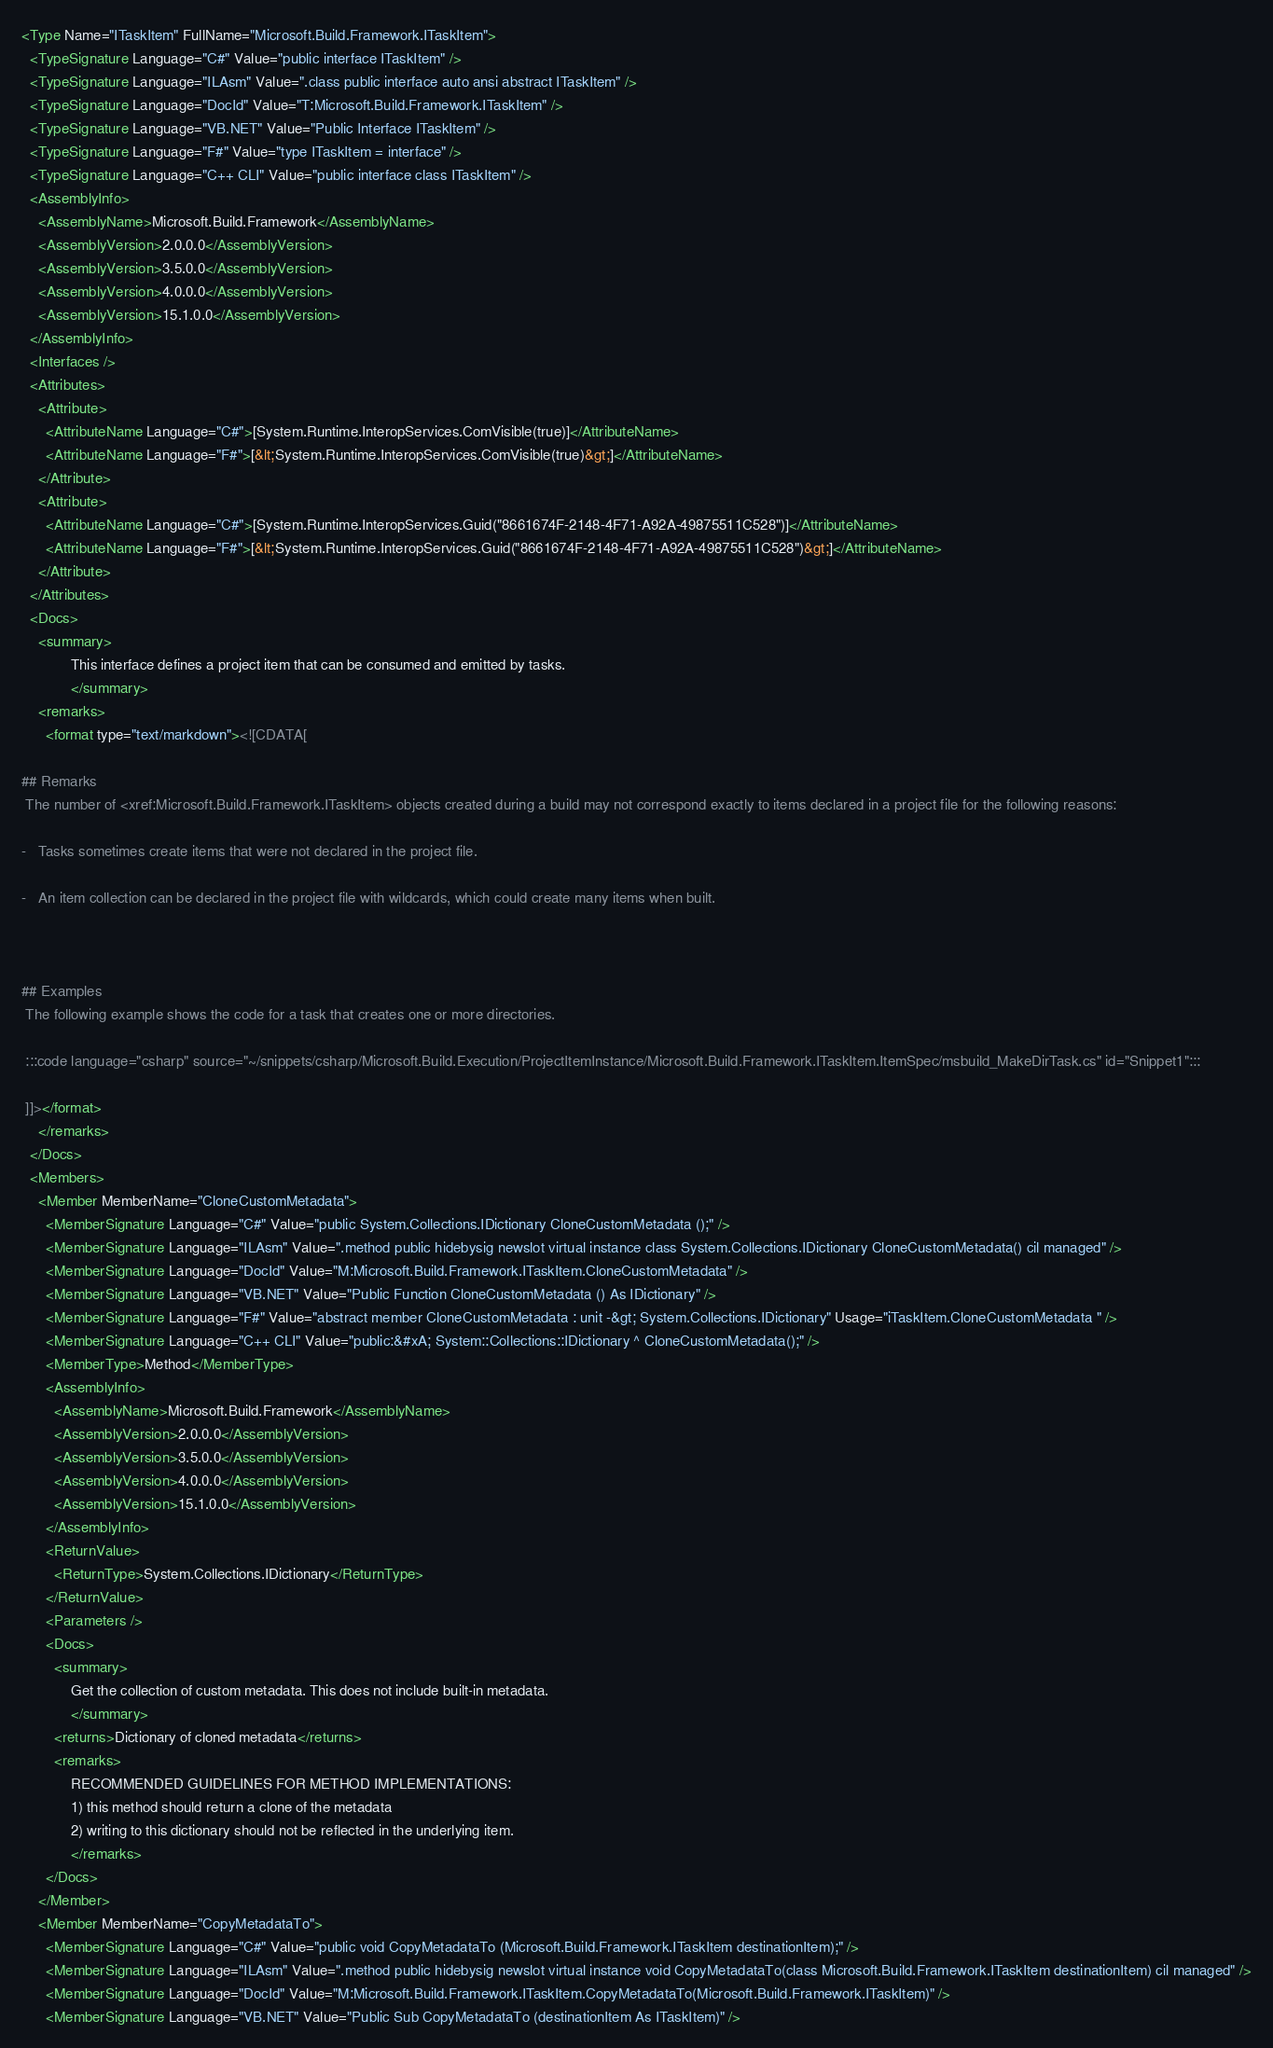Convert code to text. <code><loc_0><loc_0><loc_500><loc_500><_XML_><Type Name="ITaskItem" FullName="Microsoft.Build.Framework.ITaskItem">
  <TypeSignature Language="C#" Value="public interface ITaskItem" />
  <TypeSignature Language="ILAsm" Value=".class public interface auto ansi abstract ITaskItem" />
  <TypeSignature Language="DocId" Value="T:Microsoft.Build.Framework.ITaskItem" />
  <TypeSignature Language="VB.NET" Value="Public Interface ITaskItem" />
  <TypeSignature Language="F#" Value="type ITaskItem = interface" />
  <TypeSignature Language="C++ CLI" Value="public interface class ITaskItem" />
  <AssemblyInfo>
    <AssemblyName>Microsoft.Build.Framework</AssemblyName>
    <AssemblyVersion>2.0.0.0</AssemblyVersion>
    <AssemblyVersion>3.5.0.0</AssemblyVersion>
    <AssemblyVersion>4.0.0.0</AssemblyVersion>
    <AssemblyVersion>15.1.0.0</AssemblyVersion>
  </AssemblyInfo>
  <Interfaces />
  <Attributes>
    <Attribute>
      <AttributeName Language="C#">[System.Runtime.InteropServices.ComVisible(true)]</AttributeName>
      <AttributeName Language="F#">[&lt;System.Runtime.InteropServices.ComVisible(true)&gt;]</AttributeName>
    </Attribute>
    <Attribute>
      <AttributeName Language="C#">[System.Runtime.InteropServices.Guid("8661674F-2148-4F71-A92A-49875511C528")]</AttributeName>
      <AttributeName Language="F#">[&lt;System.Runtime.InteropServices.Guid("8661674F-2148-4F71-A92A-49875511C528")&gt;]</AttributeName>
    </Attribute>
  </Attributes>
  <Docs>
    <summary>
            This interface defines a project item that can be consumed and emitted by tasks.
            </summary>
    <remarks>
      <format type="text/markdown"><![CDATA[  
  
## Remarks  
 The number of <xref:Microsoft.Build.Framework.ITaskItem> objects created during a build may not correspond exactly to items declared in a project file for the following reasons:  
  
-   Tasks sometimes create items that were not declared in the project file.  
  
-   An item collection can be declared in the project file with wildcards, which could create many items when built.  
  
   
  
## Examples  
 The following example shows the code for a task that creates one or more directories.  
  
 :::code language="csharp" source="~/snippets/csharp/Microsoft.Build.Execution/ProjectItemInstance/Microsoft.Build.Framework.ITaskItem.ItemSpec/msbuild_MakeDirTask.cs" id="Snippet1":::  
  
 ]]></format>
    </remarks>
  </Docs>
  <Members>
    <Member MemberName="CloneCustomMetadata">
      <MemberSignature Language="C#" Value="public System.Collections.IDictionary CloneCustomMetadata ();" />
      <MemberSignature Language="ILAsm" Value=".method public hidebysig newslot virtual instance class System.Collections.IDictionary CloneCustomMetadata() cil managed" />
      <MemberSignature Language="DocId" Value="M:Microsoft.Build.Framework.ITaskItem.CloneCustomMetadata" />
      <MemberSignature Language="VB.NET" Value="Public Function CloneCustomMetadata () As IDictionary" />
      <MemberSignature Language="F#" Value="abstract member CloneCustomMetadata : unit -&gt; System.Collections.IDictionary" Usage="iTaskItem.CloneCustomMetadata " />
      <MemberSignature Language="C++ CLI" Value="public:&#xA; System::Collections::IDictionary ^ CloneCustomMetadata();" />
      <MemberType>Method</MemberType>
      <AssemblyInfo>
        <AssemblyName>Microsoft.Build.Framework</AssemblyName>
        <AssemblyVersion>2.0.0.0</AssemblyVersion>
        <AssemblyVersion>3.5.0.0</AssemblyVersion>
        <AssemblyVersion>4.0.0.0</AssemblyVersion>
        <AssemblyVersion>15.1.0.0</AssemblyVersion>
      </AssemblyInfo>
      <ReturnValue>
        <ReturnType>System.Collections.IDictionary</ReturnType>
      </ReturnValue>
      <Parameters />
      <Docs>
        <summary>
            Get the collection of custom metadata. This does not include built-in metadata.
            </summary>
        <returns>Dictionary of cloned metadata</returns>
        <remarks>
            RECOMMENDED GUIDELINES FOR METHOD IMPLEMENTATIONS:
            1) this method should return a clone of the metadata
            2) writing to this dictionary should not be reflected in the underlying item.
            </remarks>
      </Docs>
    </Member>
    <Member MemberName="CopyMetadataTo">
      <MemberSignature Language="C#" Value="public void CopyMetadataTo (Microsoft.Build.Framework.ITaskItem destinationItem);" />
      <MemberSignature Language="ILAsm" Value=".method public hidebysig newslot virtual instance void CopyMetadataTo(class Microsoft.Build.Framework.ITaskItem destinationItem) cil managed" />
      <MemberSignature Language="DocId" Value="M:Microsoft.Build.Framework.ITaskItem.CopyMetadataTo(Microsoft.Build.Framework.ITaskItem)" />
      <MemberSignature Language="VB.NET" Value="Public Sub CopyMetadataTo (destinationItem As ITaskItem)" /></code> 